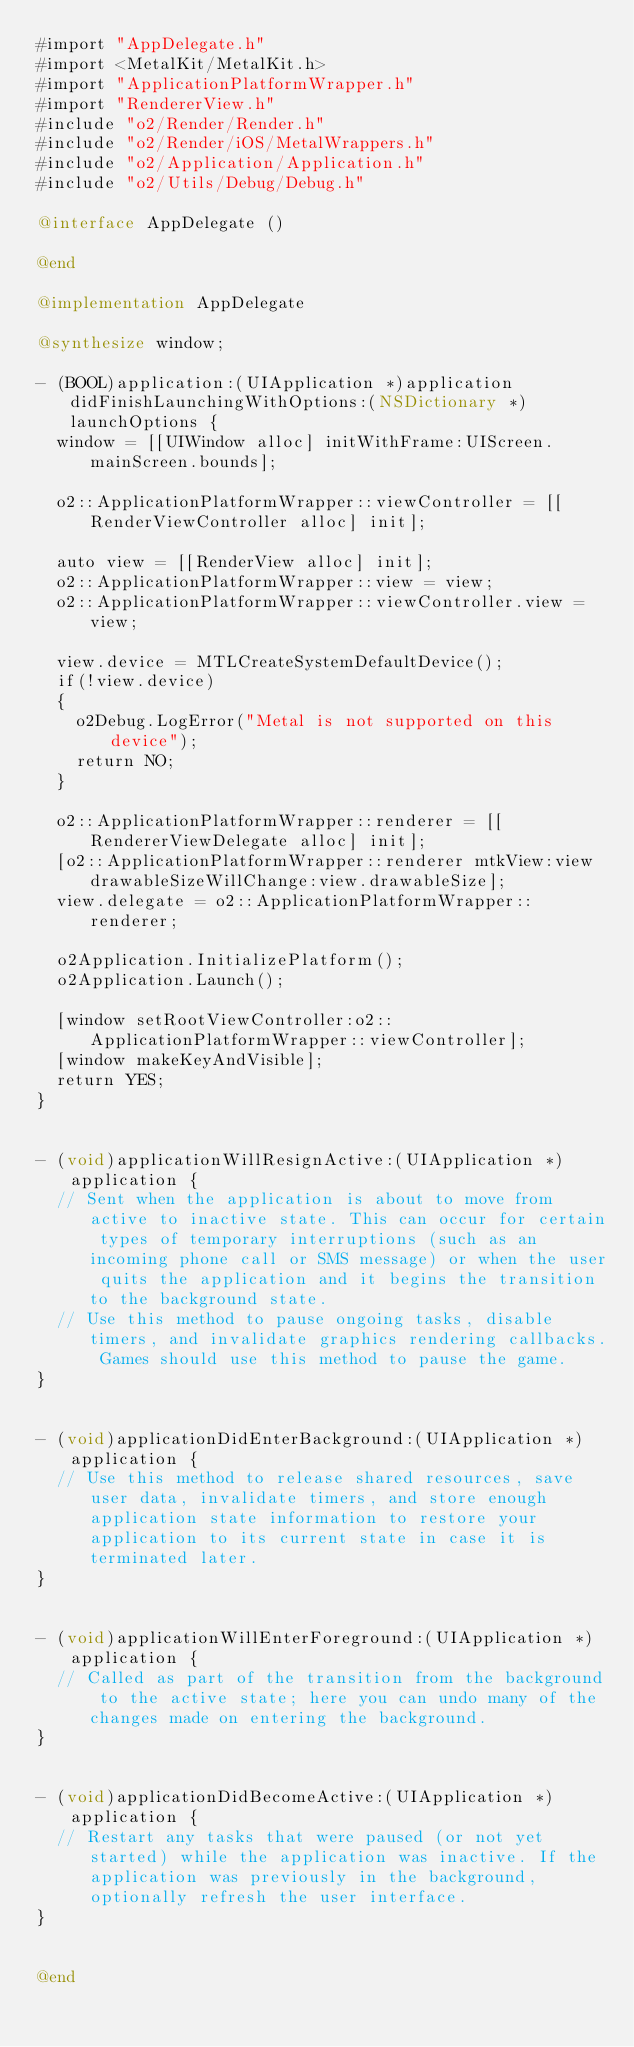<code> <loc_0><loc_0><loc_500><loc_500><_ObjectiveC_>#import "AppDelegate.h"
#import <MetalKit/MetalKit.h>
#import "ApplicationPlatformWrapper.h"
#import "RendererView.h"
#include "o2/Render/Render.h"
#include "o2/Render/iOS/MetalWrappers.h"
#include "o2/Application/Application.h"
#include "o2/Utils/Debug/Debug.h"

@interface AppDelegate ()

@end

@implementation AppDelegate

@synthesize window;

- (BOOL)application:(UIApplication *)application didFinishLaunchingWithOptions:(NSDictionary *)launchOptions {
	window = [[UIWindow alloc] initWithFrame:UIScreen.mainScreen.bounds];
	
	o2::ApplicationPlatformWrapper::viewController = [[RenderViewController alloc] init];
	
	auto view = [[RenderView alloc] init];
	o2::ApplicationPlatformWrapper::view = view;
	o2::ApplicationPlatformWrapper::viewController.view = view;
	
	view.device = MTLCreateSystemDefaultDevice();
	if(!view.device)
	{
		o2Debug.LogError("Metal is not supported on this device");
		return NO;
	}
	
	o2::ApplicationPlatformWrapper::renderer = [[RendererViewDelegate alloc] init];
	[o2::ApplicationPlatformWrapper::renderer mtkView:view drawableSizeWillChange:view.drawableSize];
	view.delegate = o2::ApplicationPlatformWrapper::renderer;
	
	o2Application.InitializePlatform();
	o2Application.Launch();
	
	[window setRootViewController:o2::ApplicationPlatformWrapper::viewController];
	[window makeKeyAndVisible];
	return YES;
}


- (void)applicationWillResignActive:(UIApplication *)application {
	// Sent when the application is about to move from active to inactive state. This can occur for certain types of temporary interruptions (such as an incoming phone call or SMS message) or when the user quits the application and it begins the transition to the background state.
	// Use this method to pause ongoing tasks, disable timers, and invalidate graphics rendering callbacks. Games should use this method to pause the game.
}


- (void)applicationDidEnterBackground:(UIApplication *)application {
	// Use this method to release shared resources, save user data, invalidate timers, and store enough application state information to restore your application to its current state in case it is terminated later.
}


- (void)applicationWillEnterForeground:(UIApplication *)application {
	// Called as part of the transition from the background to the active state; here you can undo many of the changes made on entering the background.
}


- (void)applicationDidBecomeActive:(UIApplication *)application {
	// Restart any tasks that were paused (or not yet started) while the application was inactive. If the application was previously in the background, optionally refresh the user interface.
}


@end
</code> 